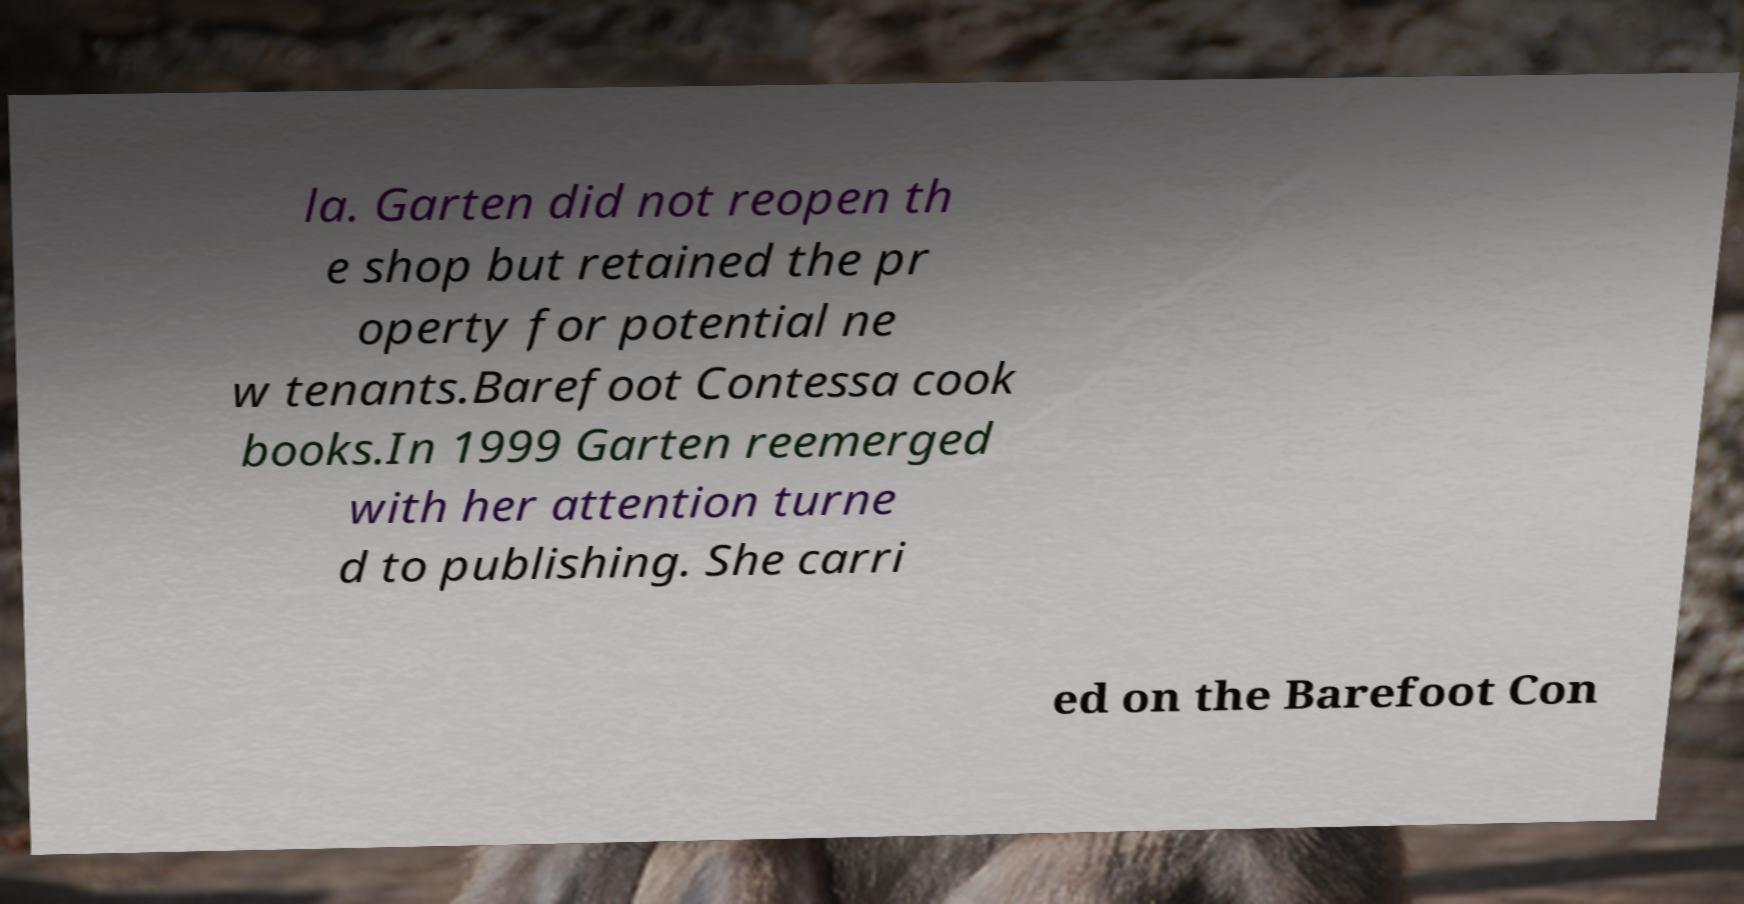Can you read and provide the text displayed in the image?This photo seems to have some interesting text. Can you extract and type it out for me? la. Garten did not reopen th e shop but retained the pr operty for potential ne w tenants.Barefoot Contessa cook books.In 1999 Garten reemerged with her attention turne d to publishing. She carri ed on the Barefoot Con 